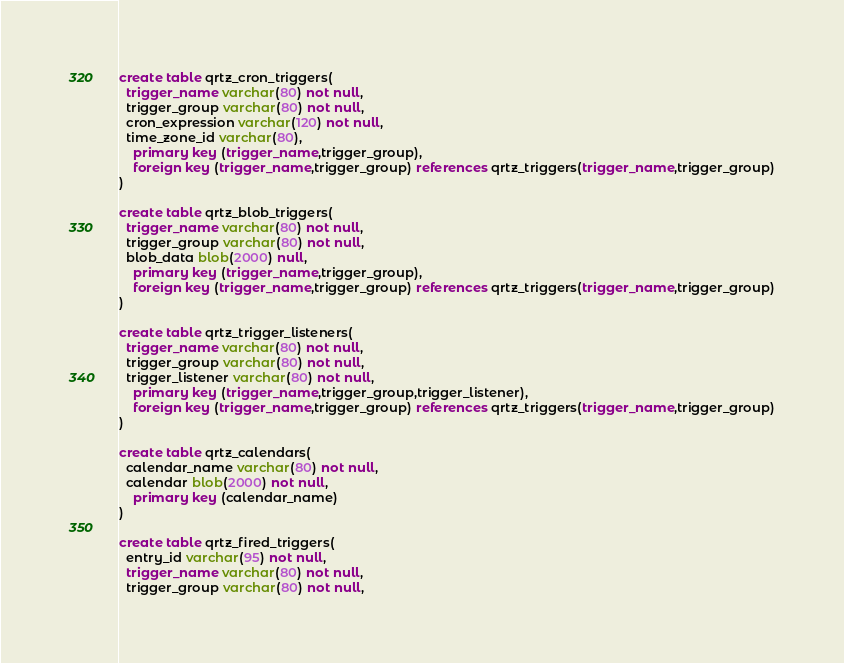Convert code to text. <code><loc_0><loc_0><loc_500><loc_500><_SQL_>create table qrtz_cron_triggers(
  trigger_name varchar(80) not null,
  trigger_group varchar(80) not null,
  cron_expression varchar(120) not null,
  time_zone_id varchar(80),
    primary key (trigger_name,trigger_group),
    foreign key (trigger_name,trigger_group) references qrtz_triggers(trigger_name,trigger_group)
)

create table qrtz_blob_triggers(
  trigger_name varchar(80) not null,
  trigger_group varchar(80) not null,
  blob_data blob(2000) null,
    primary key (trigger_name,trigger_group),
    foreign key (trigger_name,trigger_group) references qrtz_triggers(trigger_name,trigger_group)
)

create table qrtz_trigger_listeners(
  trigger_name varchar(80) not null,
  trigger_group varchar(80) not null,
  trigger_listener varchar(80) not null,
    primary key (trigger_name,trigger_group,trigger_listener),
    foreign key (trigger_name,trigger_group) references qrtz_triggers(trigger_name,trigger_group)
)

create table qrtz_calendars(
  calendar_name varchar(80) not null,
  calendar blob(2000) not null,
    primary key (calendar_name)
)

create table qrtz_fired_triggers(
  entry_id varchar(95) not null,
  trigger_name varchar(80) not null,
  trigger_group varchar(80) not null,</code> 